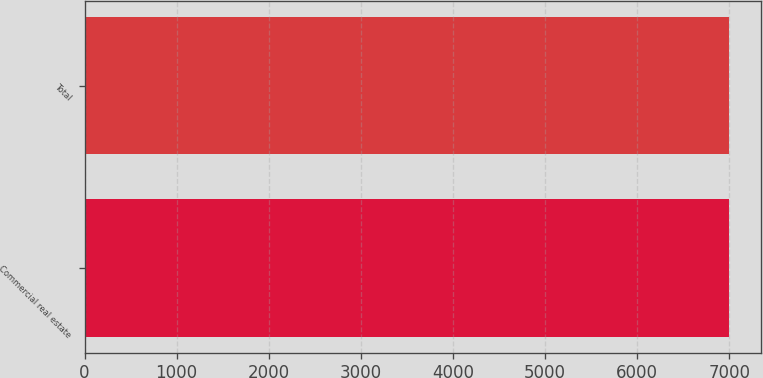Convert chart to OTSL. <chart><loc_0><loc_0><loc_500><loc_500><bar_chart><fcel>Commercial real estate<fcel>Total<nl><fcel>7000<fcel>7000.1<nl></chart> 